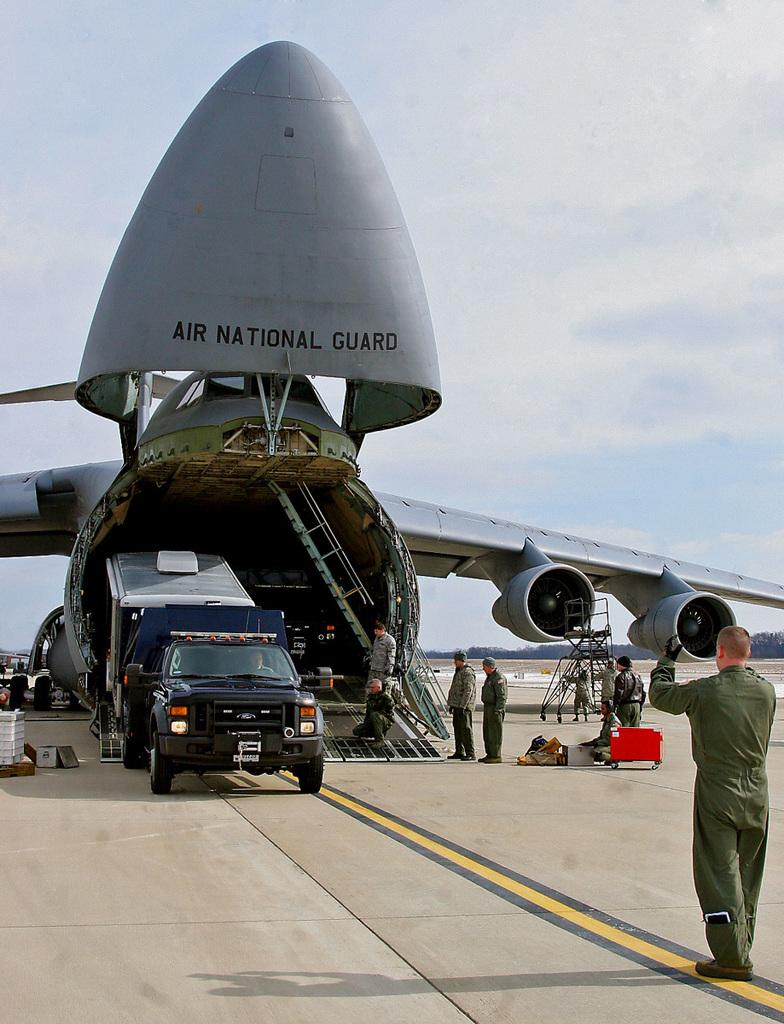<image>
Create a compact narrative representing the image presented. A large cargo plane belonging to the Air National Guard unloads cargo. 